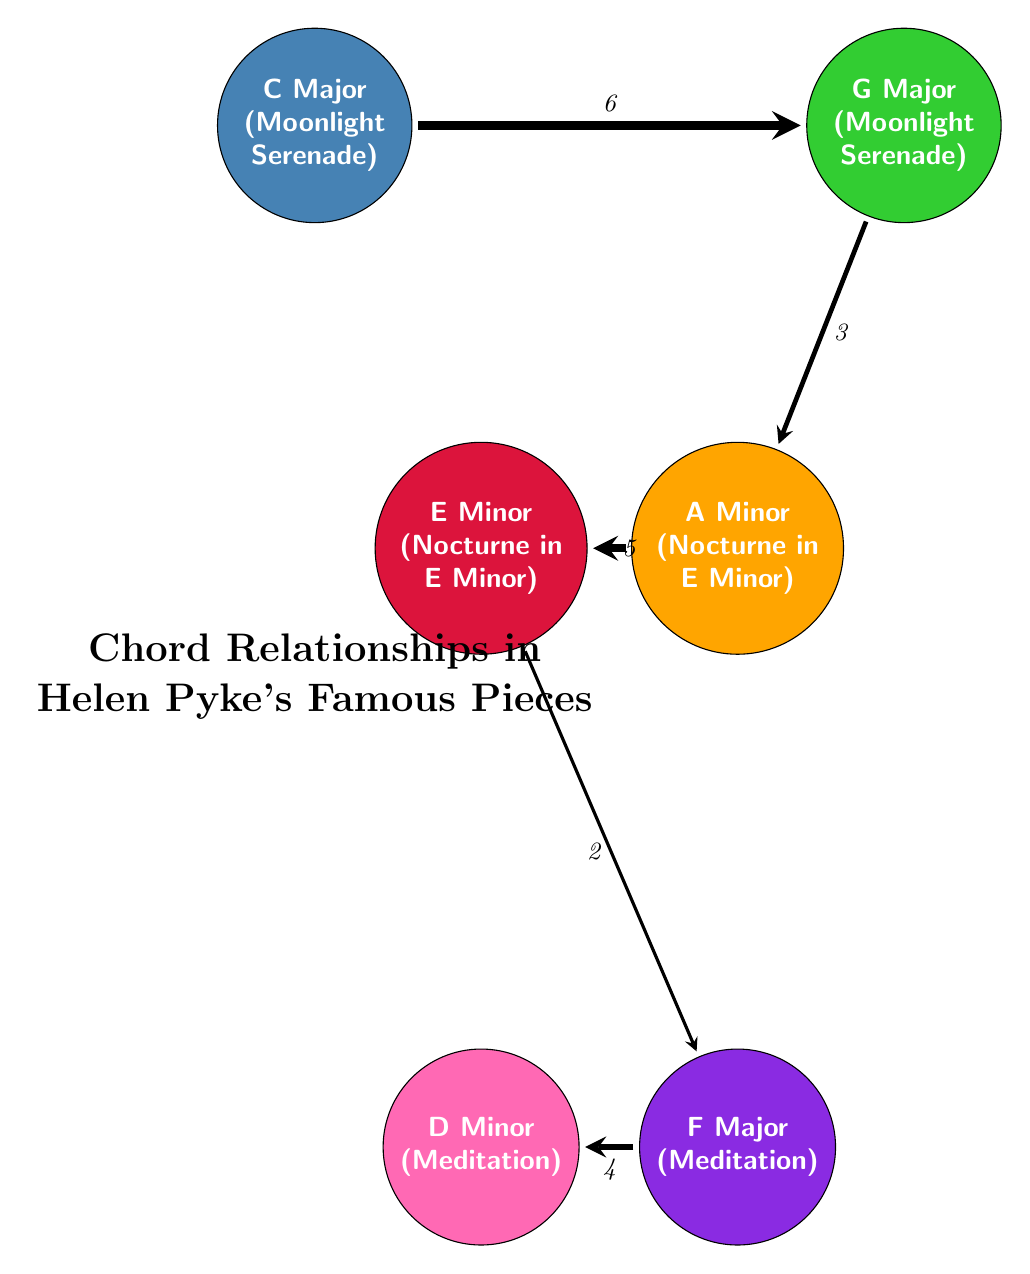What is the total number of nodes in the diagram? To find the total number of nodes, we need to count each of the unique chord nodes displayed in the diagram. There are six nodes: C Major, G Major, A Minor, E Minor, F Major, and D Minor.
Answer: 6 Which piece is associated with A Minor? A Minor is specifically linked in the diagram to "Nocturne in E Minor," which is indicated next to the A Minor node.
Answer: Nocturne in E Minor What is the weight of the connection between C Major and G Major? The weight of the connection is represented numerically in the diagram. The link connecting C Major and G Major has a value of 6, shown on the arrow between them.
Answer: 6 Which chord is connected to E Minor with the lowest weight? Reviewing the connections from E Minor in the diagram, the connection to F Major has the lowest weight of 2, which is less than the connection to A Minor (5).
Answer: F Major What is the strongest relationship among the chords represented? In the diagram, relationships are indicated by their weight values. The strongest relationship is between C Major and G Major, which has the highest weight of 6.
Answer: C Major and G Major Which two chords share a connection with a weight of 3? By examining the connections in the diagram, we see that G Major and A Minor are linked by a connection with a weight of 3, shown on the arrow between them.
Answer: G Major and A Minor Which chords are connected directly to F Major? To find the chords directly connected to F Major, we look at the diagram for all outgoing connections. F Major is connected to D Minor with a weight of 4.
Answer: D Minor What pieces are associated with C Major and F Major? By looking at the nodes' annotations in the diagram, we can see that C Major is associated with "Moonlight Serenade," while F Major is associated with "Meditation."
Answer: Moonlight Serenade and Meditation Which chord has the second highest connection weight? We assess the weights of all the connections; the second highest weight after 6 (C Major to G Major) is 5, found between A Minor and E Minor.
Answer: A Minor 